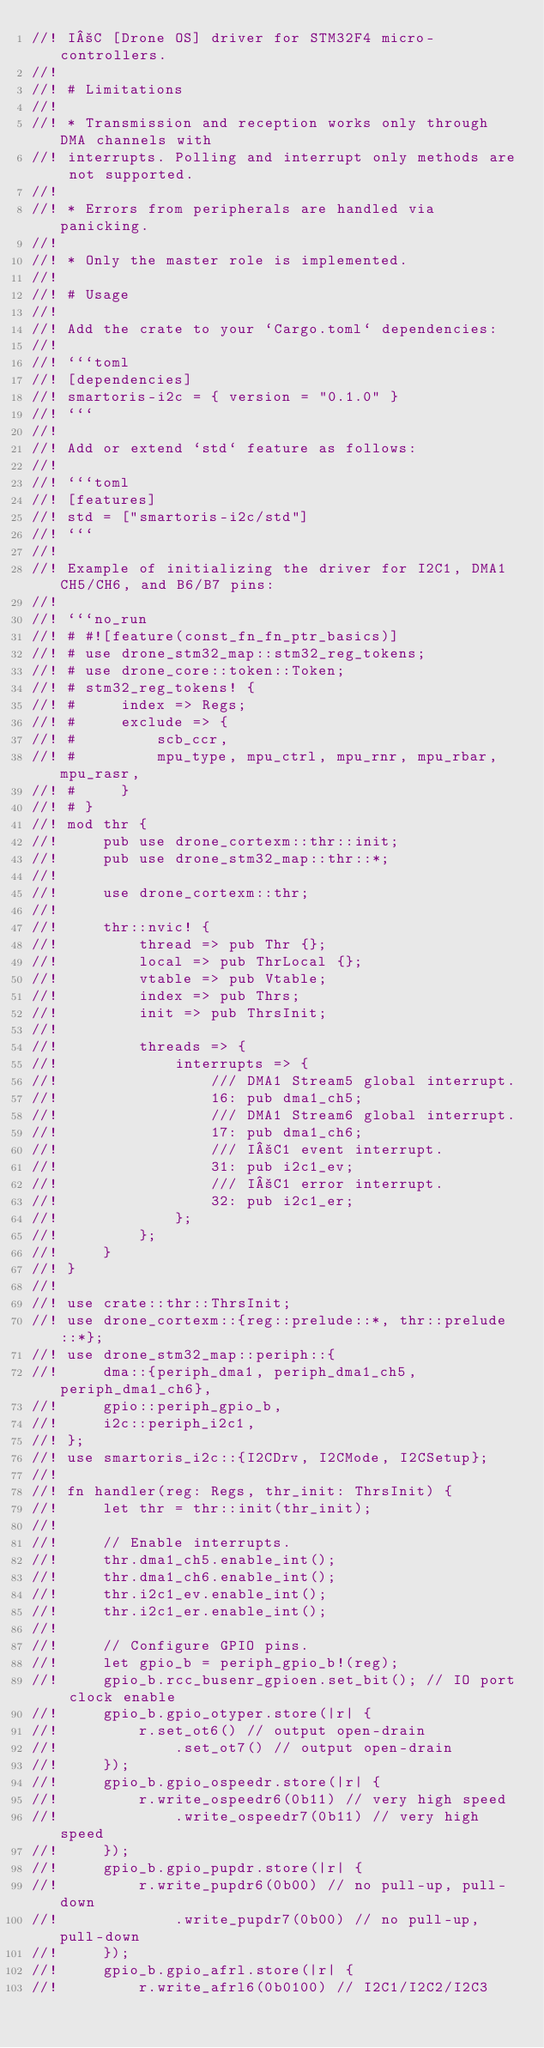<code> <loc_0><loc_0><loc_500><loc_500><_Rust_>//! I²C [Drone OS] driver for STM32F4 micro-controllers.
//!
//! # Limitations
//!
//! * Transmission and reception works only through DMA channels with
//! interrupts. Polling and interrupt only methods are not supported.
//!
//! * Errors from peripherals are handled via panicking.
//!
//! * Only the master role is implemented.
//!
//! # Usage
//!
//! Add the crate to your `Cargo.toml` dependencies:
//!
//! ```toml
//! [dependencies]
//! smartoris-i2c = { version = "0.1.0" }
//! ```
//!
//! Add or extend `std` feature as follows:
//!
//! ```toml
//! [features]
//! std = ["smartoris-i2c/std"]
//! ```
//!
//! Example of initializing the driver for I2C1, DMA1 CH5/CH6, and B6/B7 pins:
//!
//! ```no_run
//! # #![feature(const_fn_fn_ptr_basics)]
//! # use drone_stm32_map::stm32_reg_tokens;
//! # use drone_core::token::Token;
//! # stm32_reg_tokens! {
//! #     index => Regs;
//! #     exclude => {
//! #         scb_ccr,
//! #         mpu_type, mpu_ctrl, mpu_rnr, mpu_rbar, mpu_rasr,
//! #     }
//! # }
//! mod thr {
//!     pub use drone_cortexm::thr::init;
//!     pub use drone_stm32_map::thr::*;
//!
//!     use drone_cortexm::thr;
//!
//!     thr::nvic! {
//!         thread => pub Thr {};
//!         local => pub ThrLocal {};
//!         vtable => pub Vtable;
//!         index => pub Thrs;
//!         init => pub ThrsInit;
//!
//!         threads => {
//!             interrupts => {
//!                 /// DMA1 Stream5 global interrupt.
//!                 16: pub dma1_ch5;
//!                 /// DMA1 Stream6 global interrupt.
//!                 17: pub dma1_ch6;
//!                 /// I²C1 event interrupt.
//!                 31: pub i2c1_ev;
//!                 /// I²C1 error interrupt.
//!                 32: pub i2c1_er;
//!             };
//!         };
//!     }
//! }
//!
//! use crate::thr::ThrsInit;
//! use drone_cortexm::{reg::prelude::*, thr::prelude::*};
//! use drone_stm32_map::periph::{
//!     dma::{periph_dma1, periph_dma1_ch5, periph_dma1_ch6},
//!     gpio::periph_gpio_b,
//!     i2c::periph_i2c1,
//! };
//! use smartoris_i2c::{I2CDrv, I2CMode, I2CSetup};
//!
//! fn handler(reg: Regs, thr_init: ThrsInit) {
//!     let thr = thr::init(thr_init);
//!
//!     // Enable interrupts.
//!     thr.dma1_ch5.enable_int();
//!     thr.dma1_ch6.enable_int();
//!     thr.i2c1_ev.enable_int();
//!     thr.i2c1_er.enable_int();
//!
//!     // Configure GPIO pins.
//!     let gpio_b = periph_gpio_b!(reg);
//!     gpio_b.rcc_busenr_gpioen.set_bit(); // IO port clock enable
//!     gpio_b.gpio_otyper.store(|r| {
//!         r.set_ot6() // output open-drain
//!             .set_ot7() // output open-drain
//!     });
//!     gpio_b.gpio_ospeedr.store(|r| {
//!         r.write_ospeedr6(0b11) // very high speed
//!             .write_ospeedr7(0b11) // very high speed
//!     });
//!     gpio_b.gpio_pupdr.store(|r| {
//!         r.write_pupdr6(0b00) // no pull-up, pull-down
//!             .write_pupdr7(0b00) // no pull-up, pull-down
//!     });
//!     gpio_b.gpio_afrl.store(|r| {
//!         r.write_afrl6(0b0100) // I2C1/I2C2/I2C3</code> 